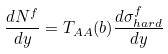Convert formula to latex. <formula><loc_0><loc_0><loc_500><loc_500>\frac { d N ^ { f } } { d y } = T _ { A A } ( b ) \frac { d \sigma ^ { f } _ { h a r d } } { d y }</formula> 